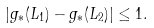<formula> <loc_0><loc_0><loc_500><loc_500>| g _ { * } ( L _ { 1 } ) - g _ { * } ( L _ { 2 } ) | \leq 1 .</formula> 